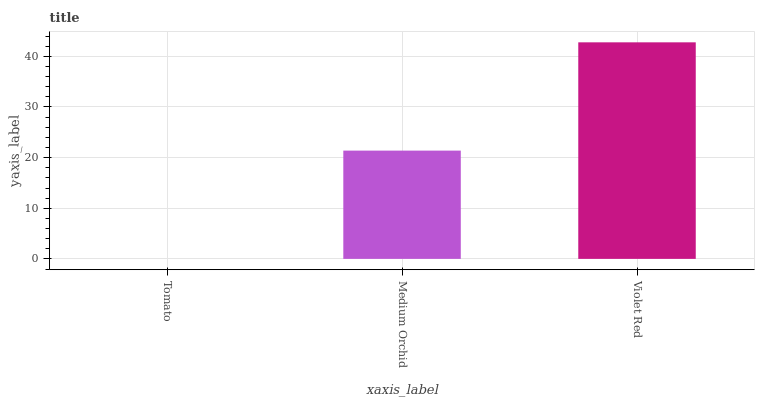Is Tomato the minimum?
Answer yes or no. Yes. Is Violet Red the maximum?
Answer yes or no. Yes. Is Medium Orchid the minimum?
Answer yes or no. No. Is Medium Orchid the maximum?
Answer yes or no. No. Is Medium Orchid greater than Tomato?
Answer yes or no. Yes. Is Tomato less than Medium Orchid?
Answer yes or no. Yes. Is Tomato greater than Medium Orchid?
Answer yes or no. No. Is Medium Orchid less than Tomato?
Answer yes or no. No. Is Medium Orchid the high median?
Answer yes or no. Yes. Is Medium Orchid the low median?
Answer yes or no. Yes. Is Violet Red the high median?
Answer yes or no. No. Is Tomato the low median?
Answer yes or no. No. 